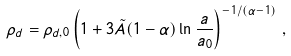Convert formula to latex. <formula><loc_0><loc_0><loc_500><loc_500>\rho _ { d } = \rho _ { d , 0 } \left ( 1 + 3 \tilde { A } ( 1 - \alpha ) \ln \frac { a } { a _ { 0 } } \right ) ^ { - 1 / ( \alpha - 1 ) } \, ,</formula> 